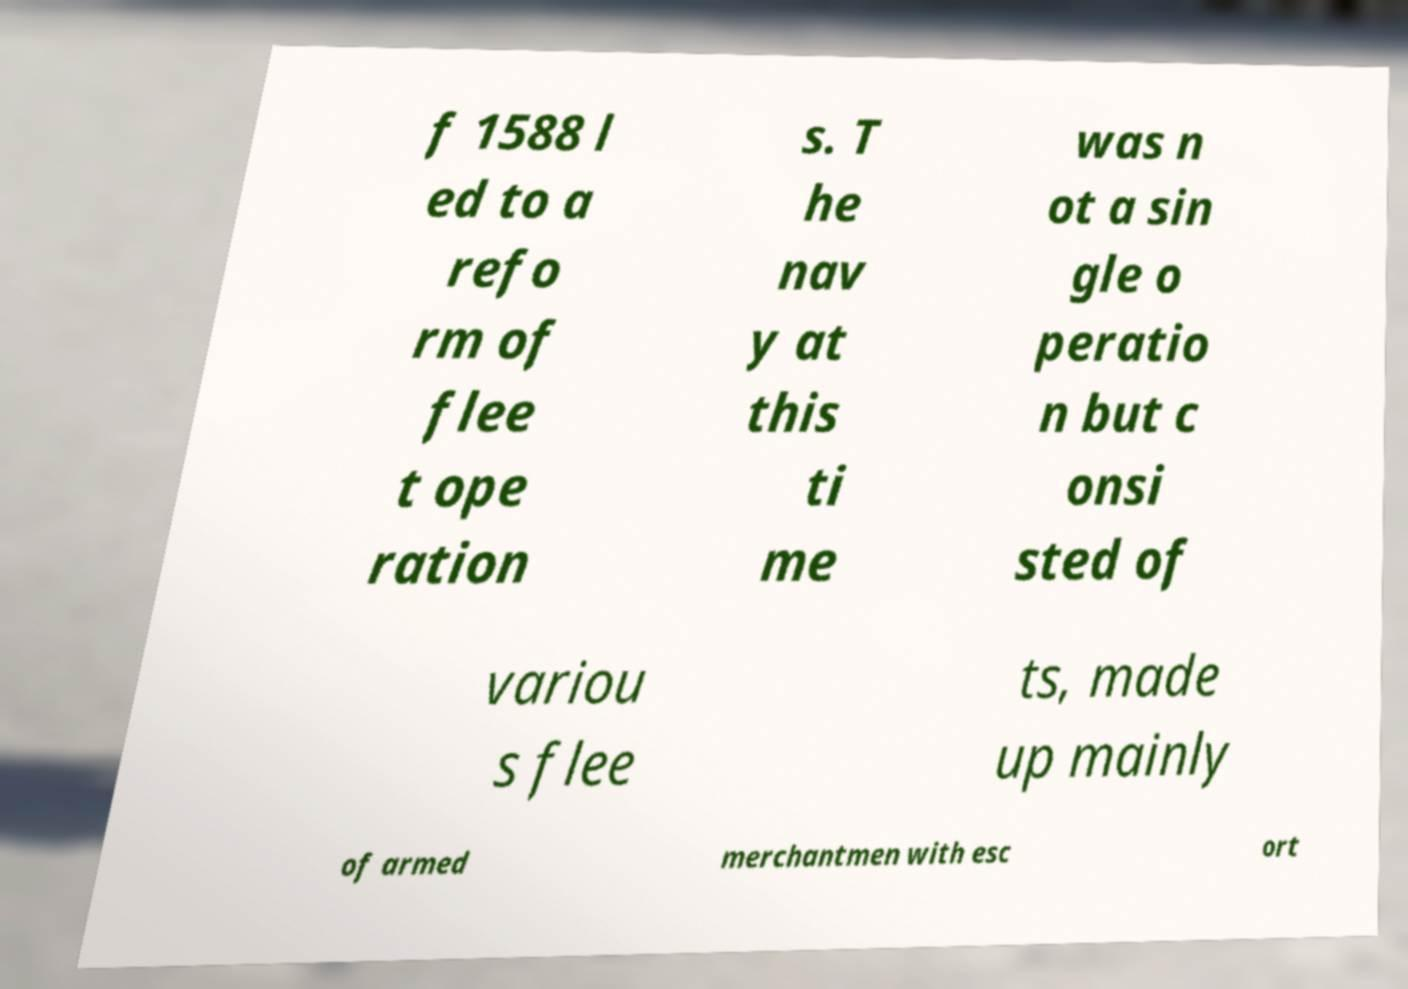Can you read and provide the text displayed in the image?This photo seems to have some interesting text. Can you extract and type it out for me? f 1588 l ed to a refo rm of flee t ope ration s. T he nav y at this ti me was n ot a sin gle o peratio n but c onsi sted of variou s flee ts, made up mainly of armed merchantmen with esc ort 